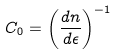<formula> <loc_0><loc_0><loc_500><loc_500>C _ { 0 } = \left ( \frac { d n } { d \epsilon } \right ) ^ { - 1 }</formula> 